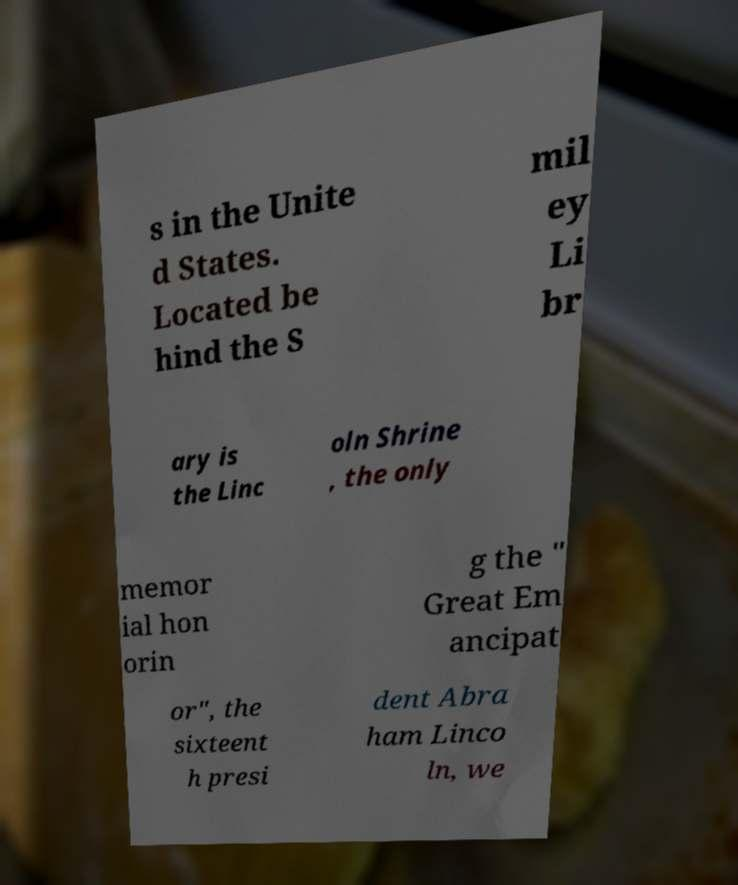What messages or text are displayed in this image? I need them in a readable, typed format. s in the Unite d States. Located be hind the S mil ey Li br ary is the Linc oln Shrine , the only memor ial hon orin g the " Great Em ancipat or", the sixteent h presi dent Abra ham Linco ln, we 